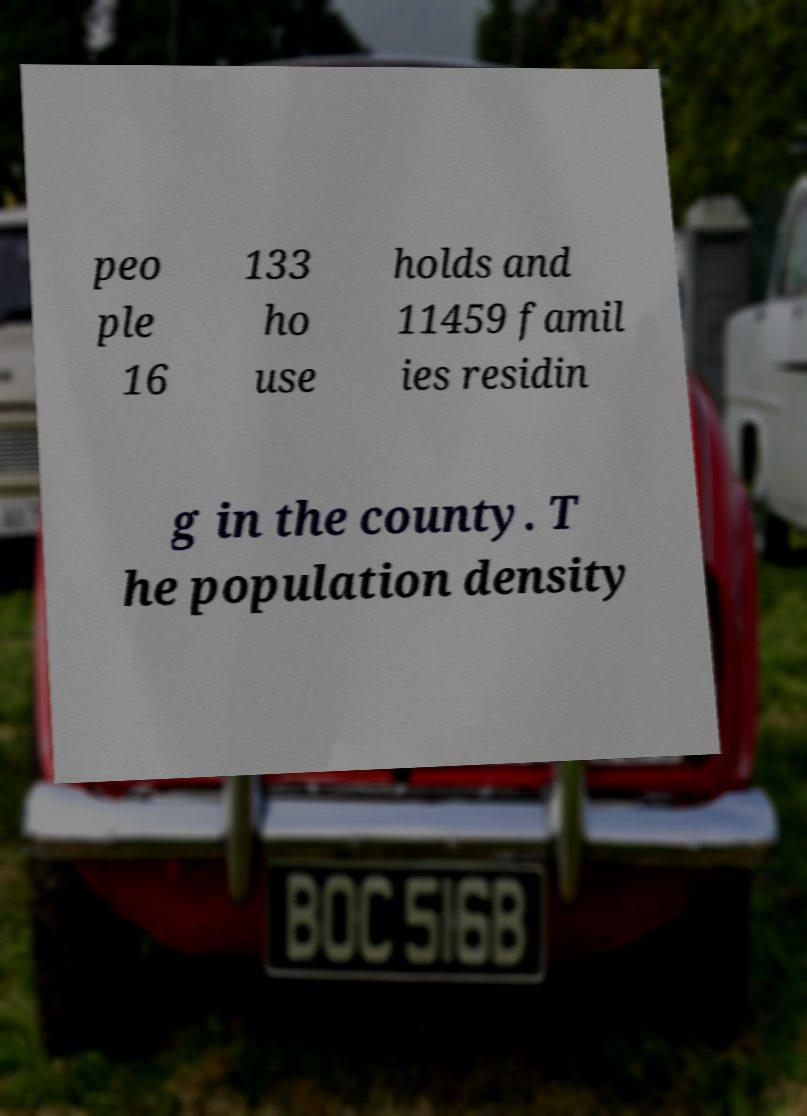Please identify and transcribe the text found in this image. peo ple 16 133 ho use holds and 11459 famil ies residin g in the county. T he population density 